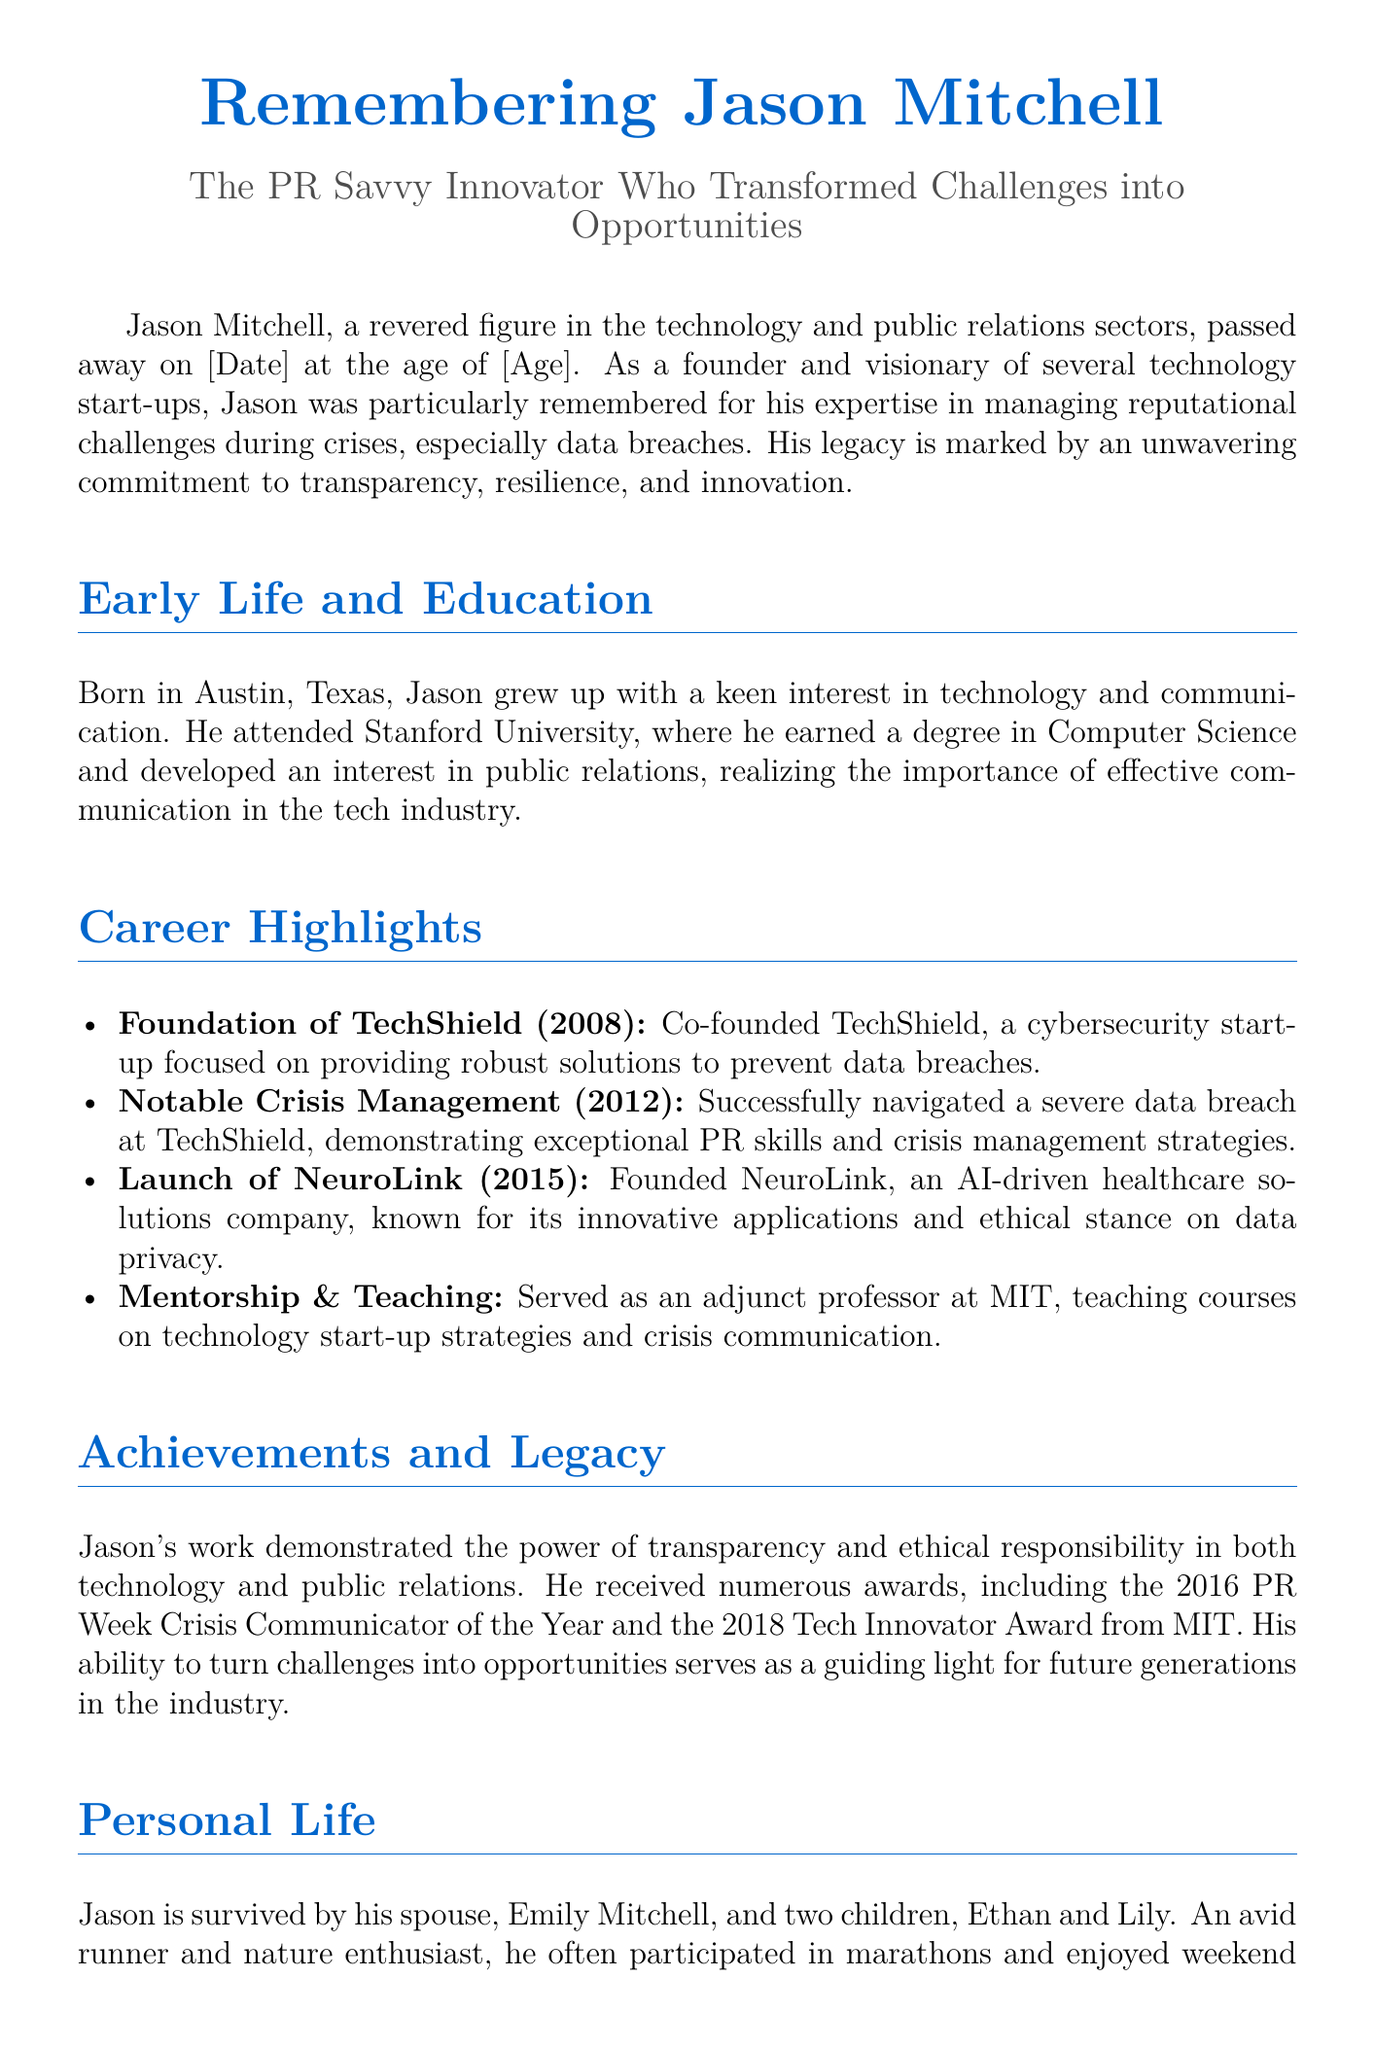What was Jason's age at the time of passing? The document states Jason passed away at the age of [Age].
Answer: [Age] What year was TechShield founded? TechShield was co-founded in 2008, as mentioned in the career highlights.
Answer: 2008 What was Jason's degree from Stanford University? He earned a degree in Computer Science, as stated in the early life and education section.
Answer: Computer Science Which award did Jason receive in 2016? The document mentions that he was awarded the 2016 PR Week Crisis Communicator of the Year.
Answer: PR Week Crisis Communicator of the Year What company did Jason co-found in 2015? The document states he founded NeuroLink in 2015, as listed in career highlights.
Answer: NeuroLink What were Jason’s two roles in education? The document indicates he served as an adjunct professor and taught courses on crisis communication.
Answer: Adjunct professor What was one of Jason's personal hobbies? The document mentions he was an avid runner, highlighting his interest in fitness.
Answer: Runner What phrase describes Jason's approach to challenges? The document refers to his ability to turn challenges into opportunities.
Answer: Challenges into opportunities 